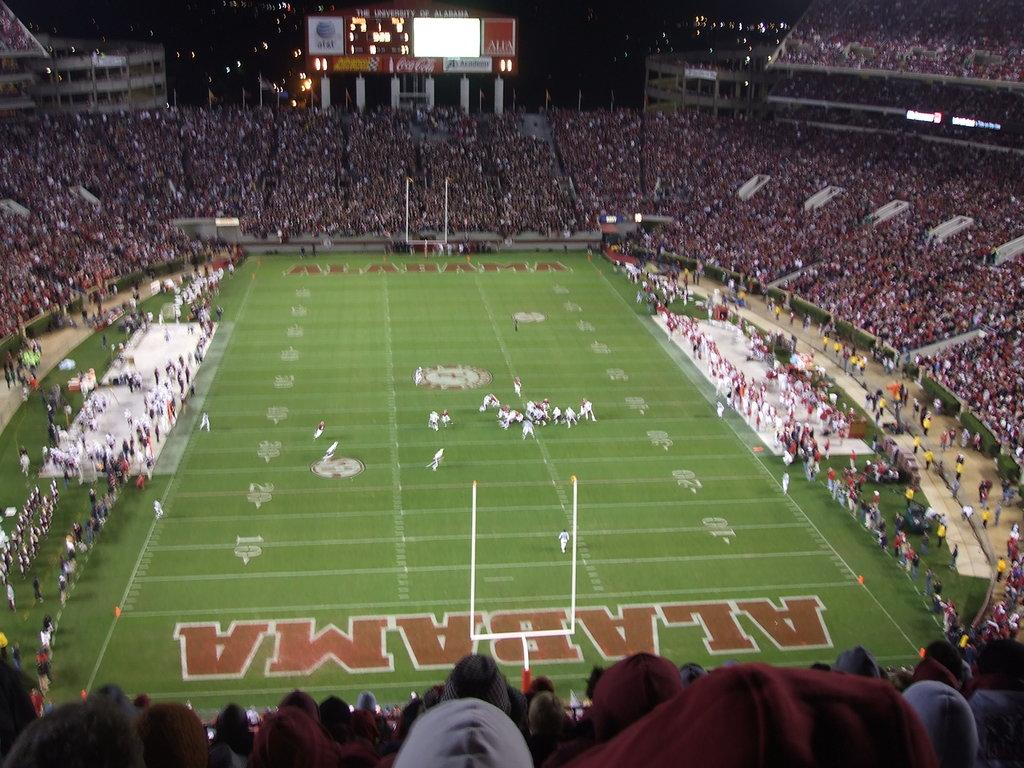What is happening on the ground in the image? There are people on the ground in the image. What can be seen in the background of the image? In the background of the image, there are stands, boards, a crowd, lights, and buildings. Can you describe the stands in the background? The stands are likely used for seating or viewing purposes. What might the lights be used for in the background? The lights could be used for illumination or to create a specific atmosphere. What type of produce is being sold at the stands in the image? There is no produce mentioned or visible in the image; the stands are not described as selling any specific items. How many boats are present in the image? There are no boats present in the image. 